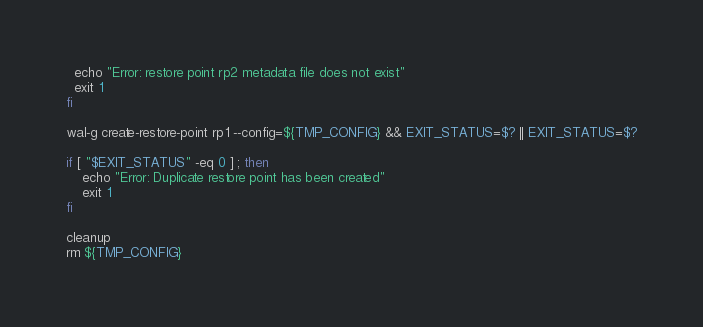Convert code to text. <code><loc_0><loc_0><loc_500><loc_500><_Bash_>  echo "Error: restore point rp2 metadata file does not exist"
  exit 1
fi

wal-g create-restore-point rp1 --config=${TMP_CONFIG} && EXIT_STATUS=$? || EXIT_STATUS=$?

if [ "$EXIT_STATUS" -eq 0 ] ; then
    echo "Error: Duplicate restore point has been created"
    exit 1
fi

cleanup
rm ${TMP_CONFIG}
</code> 